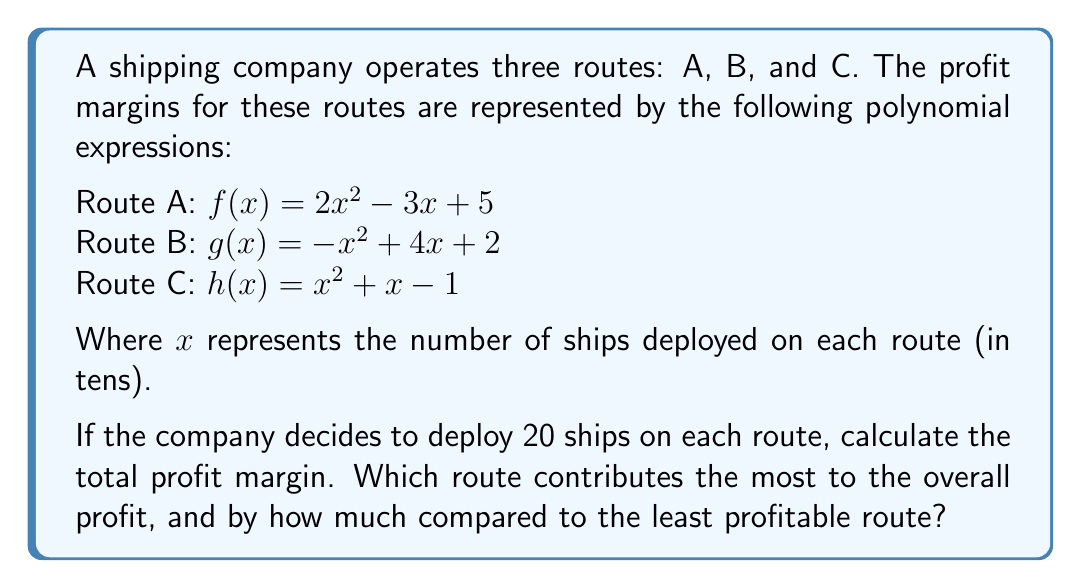Could you help me with this problem? To solve this problem, we need to follow these steps:

1. Calculate the profit margin for each route with 20 ships (x = 2):

Route A: $f(2) = 2(2)^2 - 3(2) + 5 = 2(4) - 6 + 5 = 8 - 6 + 5 = 7$

Route B: $g(2) = -(2)^2 + 4(2) + 2 = -4 + 8 + 2 = 6$

Route C: $h(2) = (2)^2 + 2 - 1 = 4 + 2 - 1 = 5$

2. Calculate the total profit margin by adding the results:
Total profit margin = $7 + 6 + 5 = 18$

3. Identify the most and least profitable routes:
Most profitable: Route A (7)
Least profitable: Route C (5)

4. Calculate the difference between the most and least profitable routes:
Difference = $7 - 5 = 2$
Answer: The total profit margin is 18. Route A contributes the most to the overall profit, exceeding the least profitable route (Route C) by 2 units. 